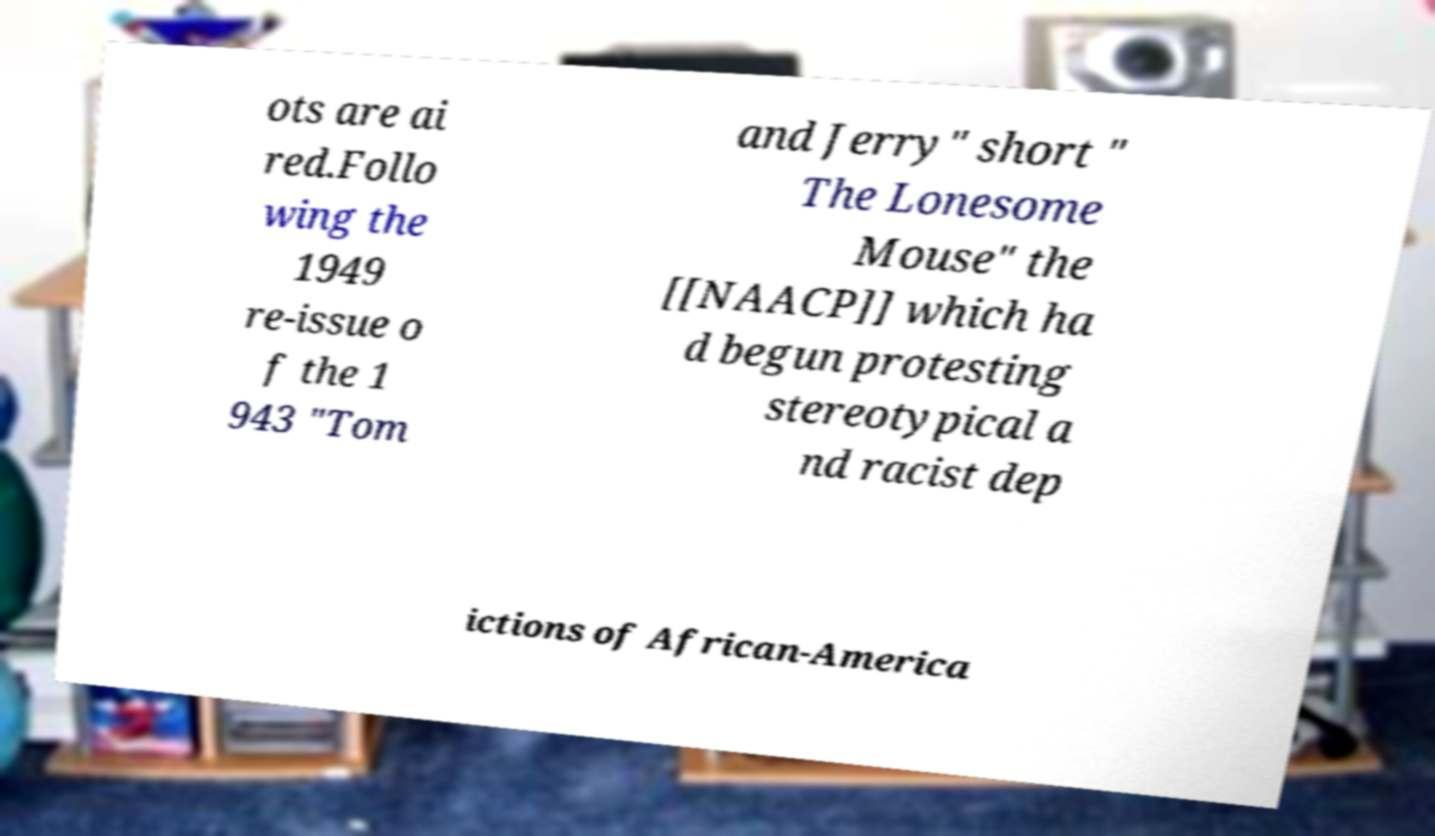Could you extract and type out the text from this image? ots are ai red.Follo wing the 1949 re-issue o f the 1 943 "Tom and Jerry" short " The Lonesome Mouse" the [[NAACP]] which ha d begun protesting stereotypical a nd racist dep ictions of African-America 